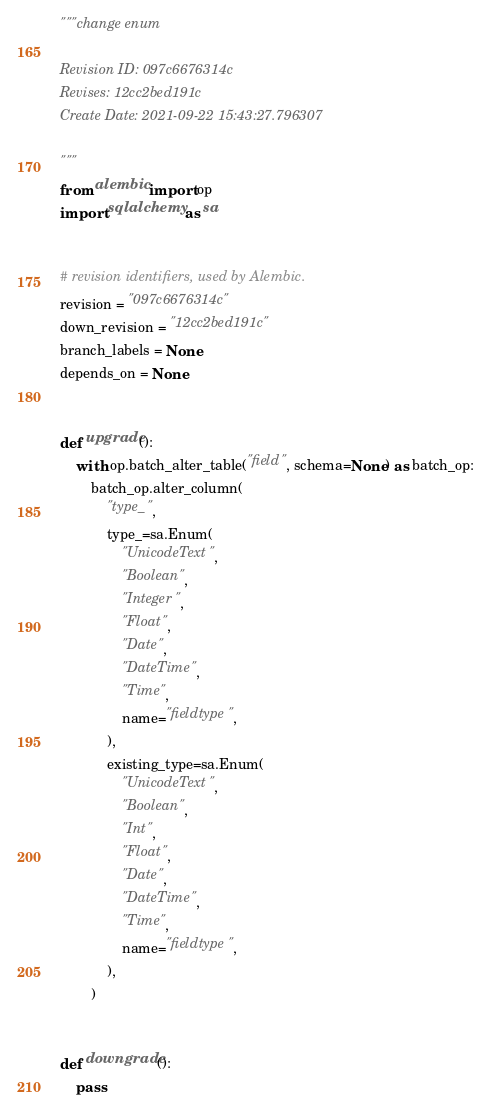<code> <loc_0><loc_0><loc_500><loc_500><_Python_>"""change enum

Revision ID: 097c6676314c
Revises: 12cc2bed191c
Create Date: 2021-09-22 15:43:27.796307

"""
from alembic import op
import sqlalchemy as sa


# revision identifiers, used by Alembic.
revision = "097c6676314c"
down_revision = "12cc2bed191c"
branch_labels = None
depends_on = None


def upgrade():
    with op.batch_alter_table("field", schema=None) as batch_op:
        batch_op.alter_column(
            "type_",
            type_=sa.Enum(
                "UnicodeText",
                "Boolean",
                "Integer",
                "Float",
                "Date",
                "DateTime",
                "Time",
                name="fieldtype",
            ),
            existing_type=sa.Enum(
                "UnicodeText",
                "Boolean",
                "Int",
                "Float",
                "Date",
                "DateTime",
                "Time",
                name="fieldtype",
            ),
        )


def downgrade():
    pass
</code> 